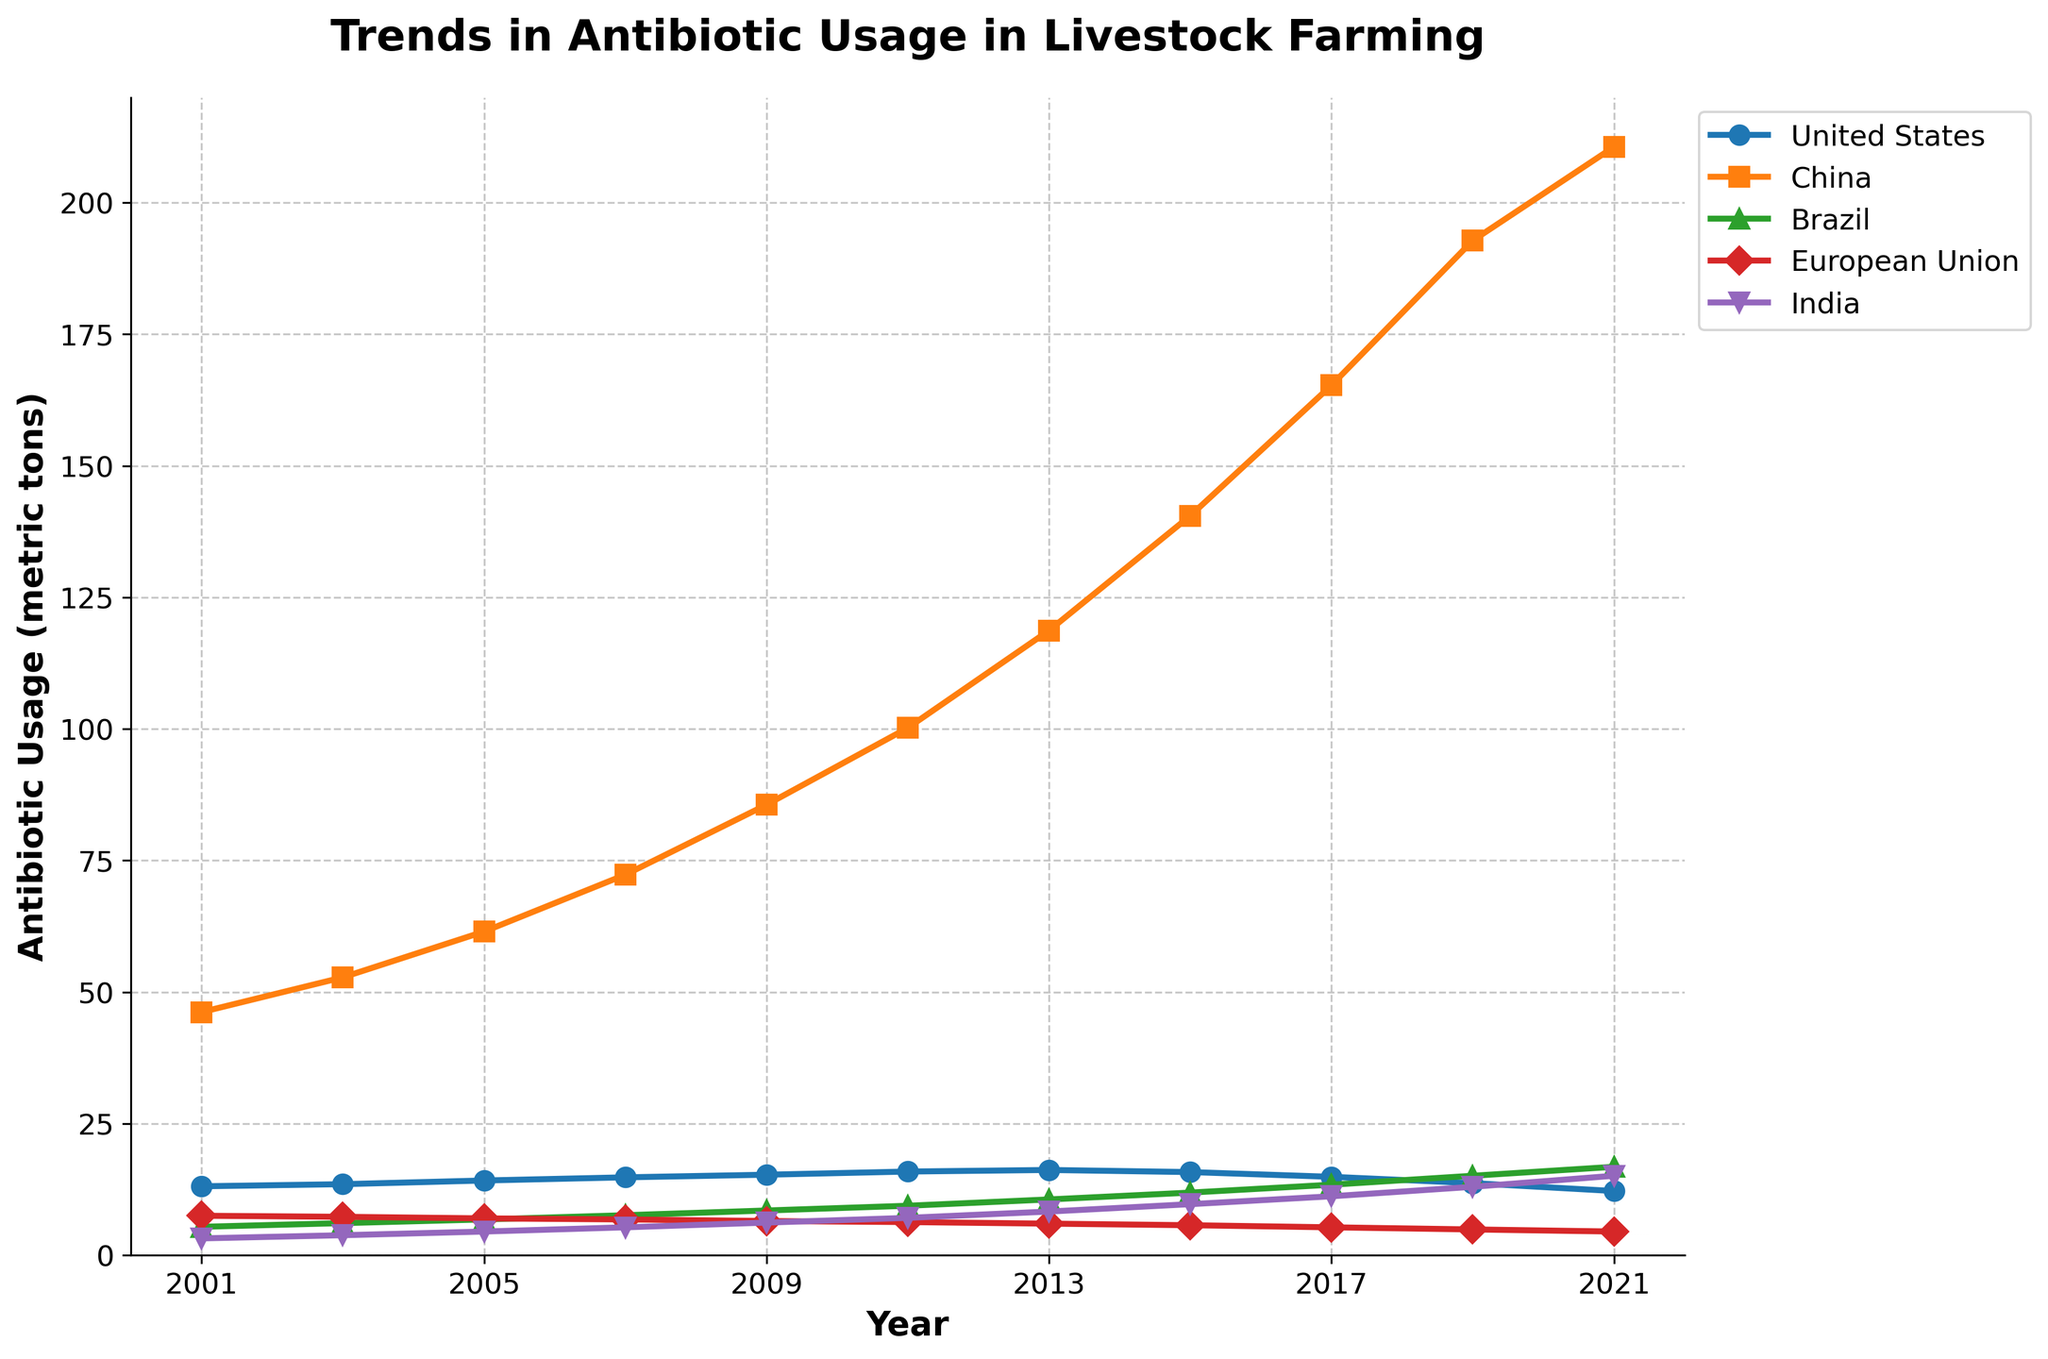What's the trend in antibiotic usage for China from 2001 to 2021? To determine the trend, observe the line representing China from 2001 to 2021. The line consistently ascends from 46.2 metric tons in 2001 to 210.6 metric tons in 2021, indicating an increasing trend.
Answer: Increasing Which country had the highest antibiotic usage in 2021? Look at the endpoints of the lines at the 2021 mark. China's endpoint is the highest among all countries at 210.6 metric tons.
Answer: China What is the average antibiotic usage in the European Union between 2001 and 2021? To find the average, add the antibiotic usage values for the European Union from 2001 to 2021 and then divide by the number of years. Sum is 7.5 + 7.3 + 7.0 + 6.8 + 6.5 + 6.3 + 6.0 + 5.7 + 5.3 + 4.9 + 4.5 = 67.8. Divide by 11 (number of data points) to get 6.16 metric tons.
Answer: 6.16 By how much did antibiotic usage increase in Brazil from 2001 to 2021? Subtract the 2001 value for Brazil (5.4 metric tons) from the 2021 value (16.8 metric tons). The difference is 16.8 - 5.4 = 11.4 metric tons.
Answer: 11.4 In which year did India’s antibiotic usage surpass 10 metric tons? Look at India's line and identify the first year where the value exceeds 10 metric tons. In 2017, India had an antibiotic usage of 11.2 metric tons.
Answer: 2017 Compare the antibiotic usage in the United States and Brazil in 2013. Which country used more, and by how much? Check the 2013 points for both the United States (16.2 metric tons) and Brazil (10.6 metric tons). The United States used more antibiotics. The difference is 16.2 - 10.6 = 5.6 metric tons.
Answer: United States, 5.6 Which country showed a decrease in antibiotic usage between 2013 and 2021? Observe the trend lines for each country between 2013 and 2021. The European Union's line clearly decreases from 6.0 metric tons in 2013 to 4.5 metric tons in 2021.
Answer: European Union What is the combined antibiotic usage of all countries in 2009? Add the 2009 values for all five countries: 15.3 (US) + 85.6 (China) + 8.5 (Brazil) + 6.5 (EU) + 6.2 (India) = 122.1 metric tons.
Answer: 122.1 How did antibiotic usage in the European Union change from 2001 to 2021? Compare the values for the European Union in 2001 (7.5 metric tons) and 2021 (4.5 metric tons). Notice that the usage decreased from 7.5 to 4.5 metric tons.
Answer: Decreased 